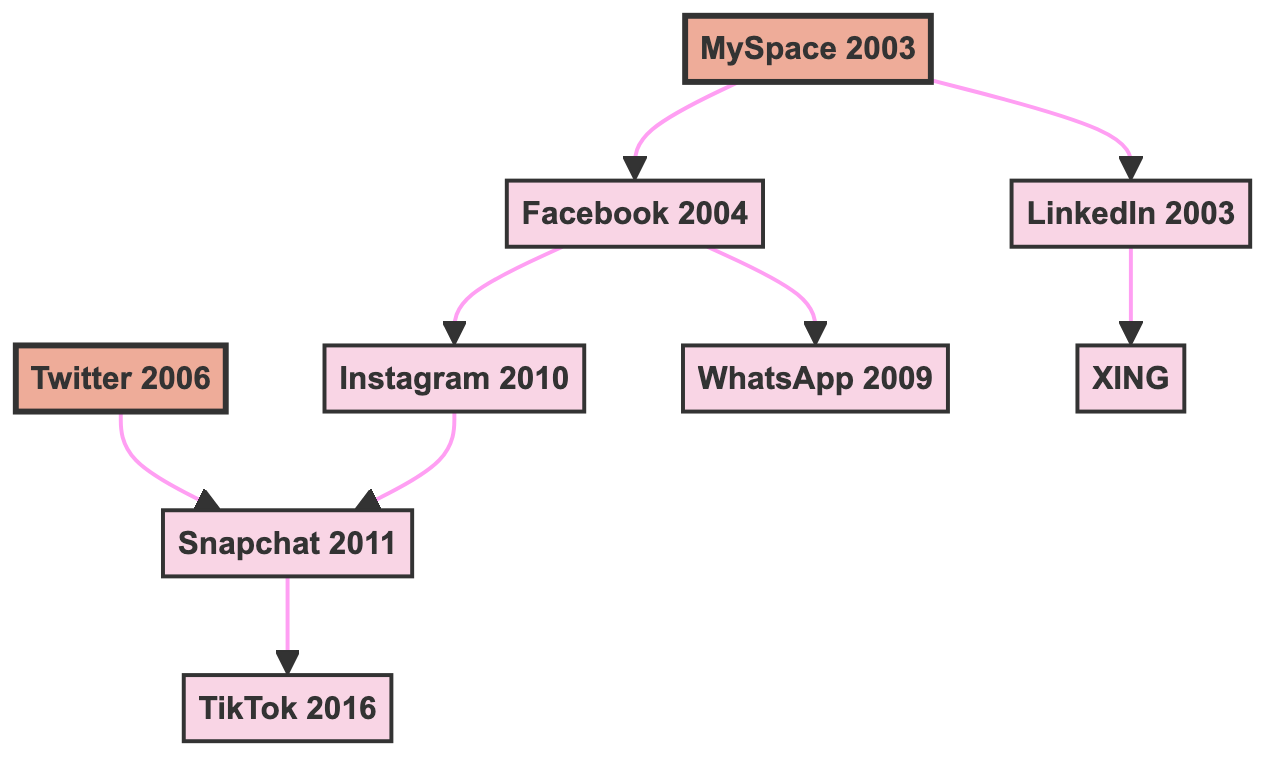What year was MySpace launched? The diagram indicates that MySpace was launched in 2003, as stated next to the MySpace node.
Answer: 2003 Which platform influenced Instagram? In the diagram, Facebook is shown to have influenced Instagram, as indicated by the arrow connecting the two nodes.
Answer: Facebook How many platforms are directly influenced by Facebook? The diagram shows that Facebook directly influences two platforms: Instagram and WhatsApp, which can be counted from the arrows leading from Facebook.
Answer: 2 Which platform followed Snapchat that is displayed in the diagram? According to the diagram, TikTok is influenced by Snapchat, as shown by the arrow from Snapchat to TikTok.
Answer: TikTok Which platform was influenced by both MySpace and LinkedIn? From the diagram, the platform influenced by MySpace and LinkedIn can be found by tracing influences; however, there is no platform that fits this criteria as they influence different platforms.
Answer: None What is the earliest launched platform in this diagram? The earliest launch year in the diagram is for MySpace, identified by the year 2003 next to its node, making it the oldest platform.
Answer: MySpace How many platforms have no influences listed? The diagram shows that both WhatsApp and TikTok do not have any arrows pointing to other platforms, indicating they have no influences listed. This is a count of two.
Answer: 2 Which platform was influenced by both Twitter and Instagram? The diagram shows that Snapchat is influenced by both Twitter and Instagram, as indicated by separate arrows leading to Snapchat from both platforms.
Answer: Snapchat What was the year LinkedIn was launched? The diagram clearly indicates that LinkedIn was launched in 2003, as shown next to its node.
Answer: 2003 